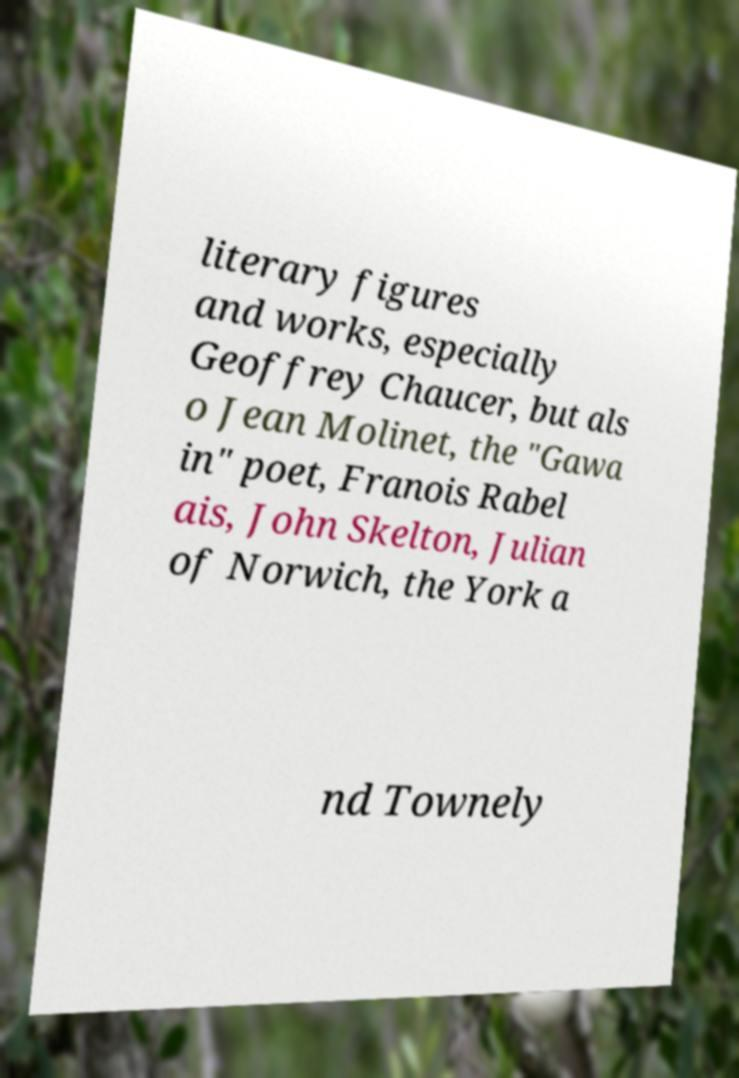Could you extract and type out the text from this image? literary figures and works, especially Geoffrey Chaucer, but als o Jean Molinet, the "Gawa in" poet, Franois Rabel ais, John Skelton, Julian of Norwich, the York a nd Townely 